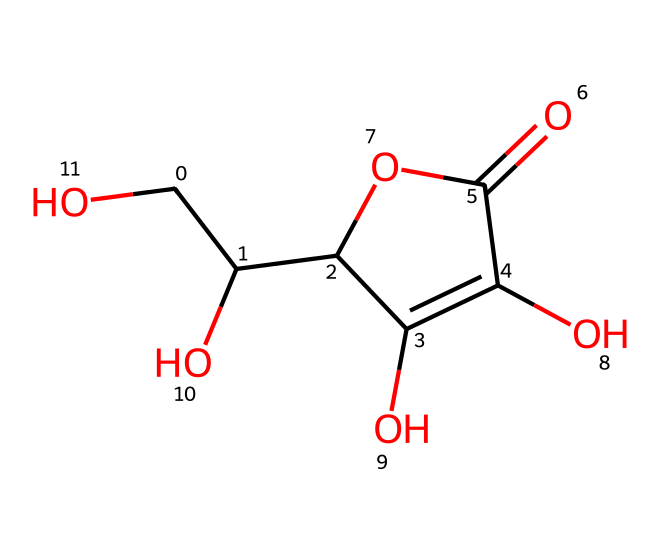What is the name of this chemical? This chemical structure corresponds to ascorbic acid, also known as Vitamin C. The name is derived from its chemical structure and functional properties.
Answer: ascorbic acid How many carbon atoms are present in this molecule? By analyzing the SMILES structure, we can identify six carbon atoms represented by the "C" symbols in the sequence.
Answer: six What functional groups are present in ascorbic acid? The chemical structure contains multiple hydroxyl groups (-OH) and a carboxylic acid group (-COOH). These groups define its properties as an organic acid and an alcohol.
Answer: hydroxyl and carboxylic acid What type of compound is ascorbic acid classified as? Ascorbic acid is classified as a vitamin, more specifically a water-soluble vitamin due to its solubility in water and biological significance.
Answer: vitamin What is the molecular formula of ascorbic acid? The molecular formula can be deduced from the SMILES representation, which gives the formula C6H8O6 through counting the respective atoms present in the structure.
Answer: C6H8O6 How does the molecular structure of ascorbic acid relate to its antioxidant properties? The molecular structure features multiple hydroxyl groups that can donate electrons, making ascorbic acid an effective antioxidant by neutralizing free radicals.
Answer: antioxidants Which part of the molecule is responsible for its acidity? The carboxylic acid group (-COOH) in the structure contributes to the acidic nature of ascorbic acid, enabling it to donate protons in solution.
Answer: -COOH 